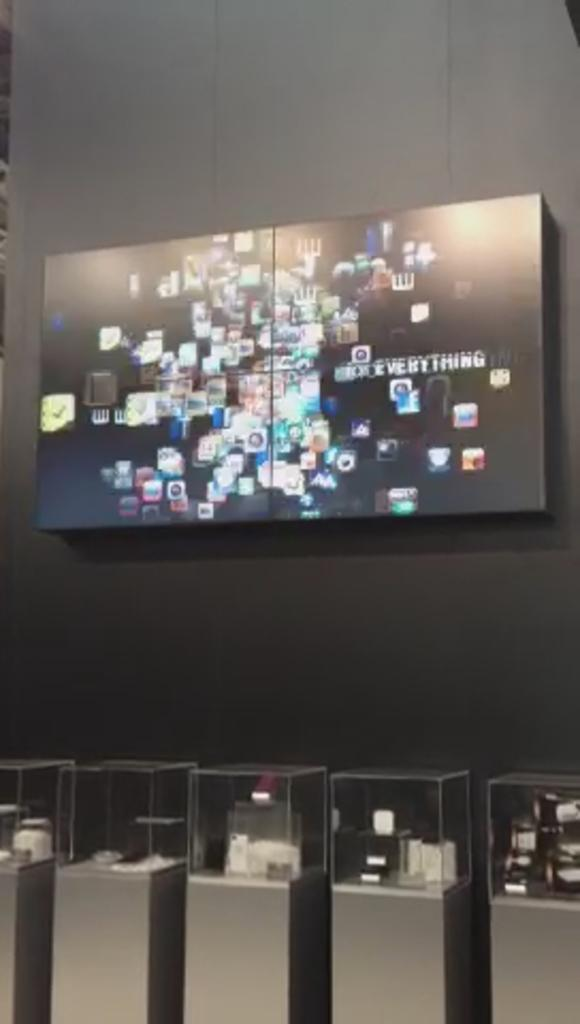<image>
Offer a succinct explanation of the picture presented. A store display with a tv that has small icons and "everything". 